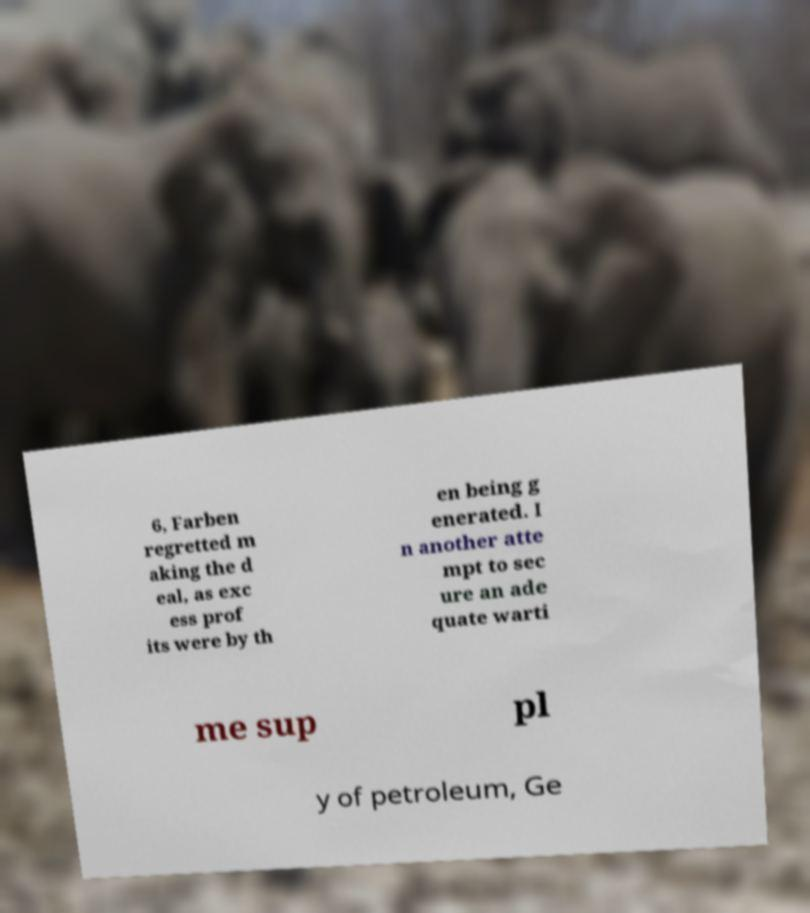There's text embedded in this image that I need extracted. Can you transcribe it verbatim? 6, Farben regretted m aking the d eal, as exc ess prof its were by th en being g enerated. I n another atte mpt to sec ure an ade quate warti me sup pl y of petroleum, Ge 